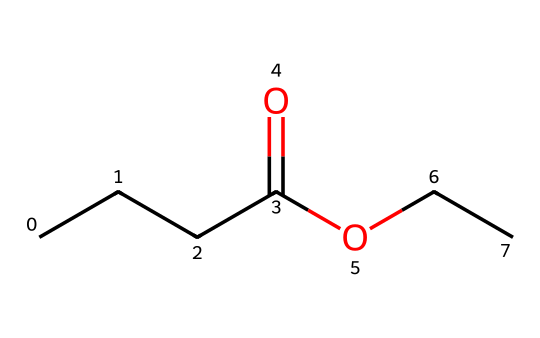What is the chemical name of this compound? The SMILES representation shows a structure with a butyrate moiety (CCCC(=O)O) connected to an ethyl group (CC), leading to the name ethyl butyrate.
Answer: ethyl butyrate How many carbon atoms are present in this molecule? Analyzing the SMILES, there are five carbon atoms in the butyrate part (CCCC) and two in the ethyl part (CC), totaling seven carbon atoms.
Answer: 7 What functional groups are present in ethyl butyrate? The structure includes a carboxylate group (the C=O and O), indicating it is an ester, specifically an ethyl ester of butyric acid.
Answer: ester What type of aroma does ethyl butyrate produce? Ethyl butyrate is well known for its fruity aroma, commonly associated with flavors like pineapple or other tropical fruits, making it popular in candies.
Answer: fruity Which component of the structure contributes to its sweet smell? The ethyl group connected to the butyric acid portion helps create a sweet aroma, characteristic of esters, known for their pleasant, fruity scents.
Answer: ethyl group What is the relationship between carbon chain length and fruity aroma intensity? Generally, as the carbon chain increases, the scent can become fruitier, which is seen in esters like ethyl butyrate, where the five-carbon chain is optimal for sweetness.
Answer: increases 